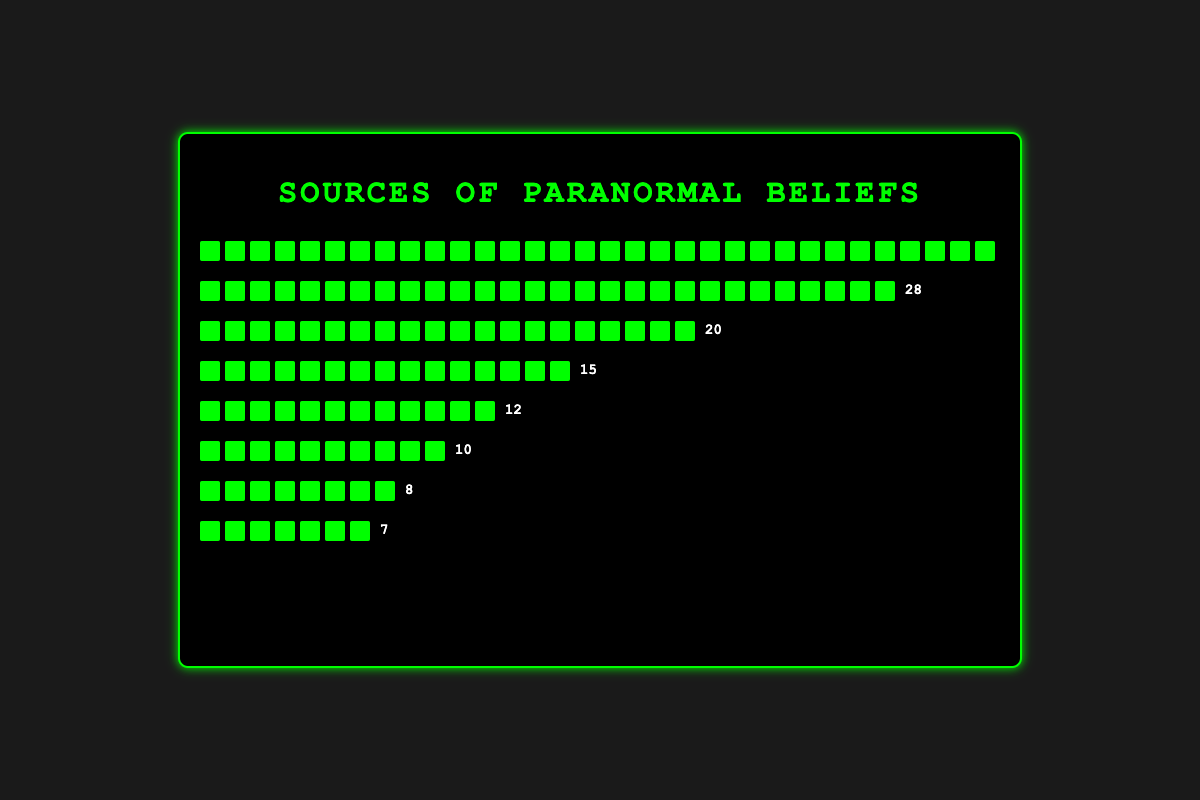What's the most common source of paranormal beliefs? The figure shows various sources of paranormal beliefs with their respective counts. The source with the highest count is "Television Shows" with 35 instances.
Answer: Television Shows Which is less influential: Personal Experiences or Religious Teachings? The figure shows "Personal Experiences" with a count of 12 and "Religious Teachings" with a count of 10. Since 10 is less than 12, "Religious Teachings" is less influential.
Answer: Religious Teachings How many more influences do Family Stories have compared to Podcasts? The count for "Family Stories" is 20, and the count for "Podcasts" is 8. By subtracting the smaller number from the larger one (20 - 8), we find that Family Stories have 12 more influences than Podcasts.
Answer: 12 What is the total number of influences listed in the figure? By summing up all the counts: 35 (Television Shows) + 28 (Social Media) + 20 (Family Stories) + 15 (Books) + 12 (Personal Experiences) + 10 (Religious Teachings) + 8 (Podcasts) + 7 (Folklore), the total is 135.
Answer: 135 Which category has slightly fewer influences: Books or Social Media? "Social Media" has a count of 28 and "Books" has a count of 15. Since 15 is slightly fewer than 28, Books have slightly fewer influences.
Answer: Books What percentage of the total influences is accounted for by Television Shows? First, find the total number of influences, which is 135. Then, calculate the percentage represented by "Television Shows" (35 / 135) * 100 which equals approximately 25.93%.
Answer: 25.93% What's the difference in influence counts between the two least influential sources? The two least influential sources are "Folklore" with 7 counts and "Podcasts" with 8 counts. The difference is 8 - 7 = 1.
Answer: 1 Is "Personal Experiences" more or less influential than "Books"? By how many? "Personal Experiences" has 12 influences, and "Books" has 15 influences. To determine if it's more or less influential, we see that 12 is less than 15. The difference is 15 - 12 = 3. So, Personal Experiences are 3 less influential than Books.
Answer: less, 3 What is the combined count of influences for Family Stories and Religious Teachings? The count for "Family Stories" is 20 and for "Religious Teachings" is 10. Adding them together gives 20 + 10 = 30.
Answer: 30 